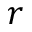<formula> <loc_0><loc_0><loc_500><loc_500>r</formula> 